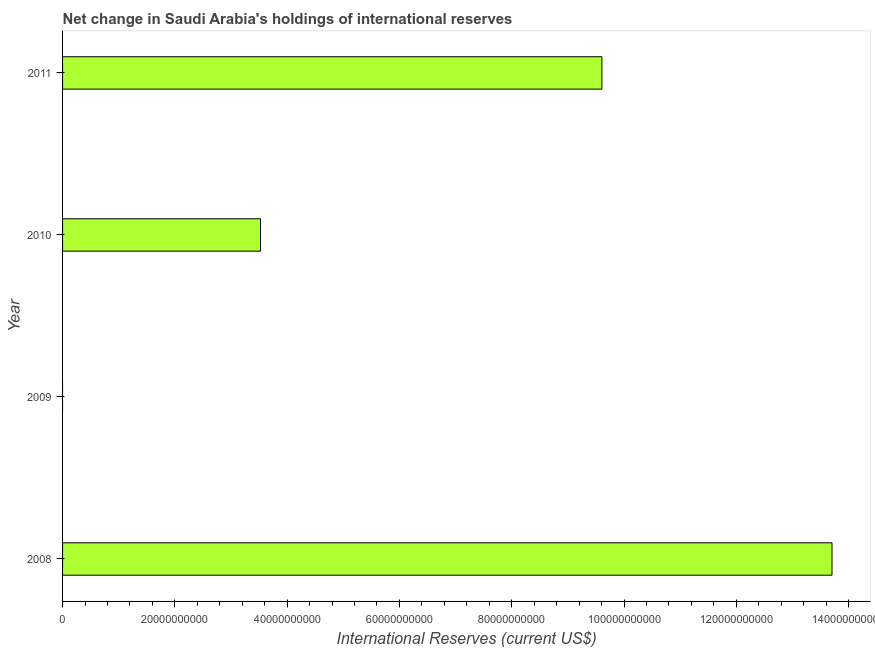Does the graph contain grids?
Your answer should be very brief. No. What is the title of the graph?
Provide a short and direct response. Net change in Saudi Arabia's holdings of international reserves. What is the label or title of the X-axis?
Make the answer very short. International Reserves (current US$). What is the reserves and related items in 2011?
Provide a short and direct response. 9.61e+1. Across all years, what is the maximum reserves and related items?
Offer a very short reply. 1.37e+11. What is the sum of the reserves and related items?
Ensure brevity in your answer.  2.68e+11. What is the difference between the reserves and related items in 2010 and 2011?
Offer a terse response. -6.08e+1. What is the average reserves and related items per year?
Make the answer very short. 6.71e+1. What is the median reserves and related items?
Provide a succinct answer. 6.57e+1. What is the ratio of the reserves and related items in 2008 to that in 2011?
Keep it short and to the point. 1.43. Is the reserves and related items in 2008 less than that in 2011?
Your response must be concise. No. What is the difference between the highest and the second highest reserves and related items?
Keep it short and to the point. 4.10e+1. Is the sum of the reserves and related items in 2008 and 2010 greater than the maximum reserves and related items across all years?
Give a very brief answer. Yes. What is the difference between the highest and the lowest reserves and related items?
Ensure brevity in your answer.  1.37e+11. In how many years, is the reserves and related items greater than the average reserves and related items taken over all years?
Keep it short and to the point. 2. How many bars are there?
Your answer should be very brief. 3. How many years are there in the graph?
Your answer should be compact. 4. What is the difference between two consecutive major ticks on the X-axis?
Make the answer very short. 2.00e+1. What is the International Reserves (current US$) in 2008?
Your response must be concise. 1.37e+11. What is the International Reserves (current US$) of 2009?
Your answer should be very brief. 0. What is the International Reserves (current US$) of 2010?
Your answer should be compact. 3.53e+1. What is the International Reserves (current US$) in 2011?
Keep it short and to the point. 9.61e+1. What is the difference between the International Reserves (current US$) in 2008 and 2010?
Give a very brief answer. 1.02e+11. What is the difference between the International Reserves (current US$) in 2008 and 2011?
Your answer should be compact. 4.10e+1. What is the difference between the International Reserves (current US$) in 2010 and 2011?
Ensure brevity in your answer.  -6.08e+1. What is the ratio of the International Reserves (current US$) in 2008 to that in 2010?
Your answer should be compact. 3.89. What is the ratio of the International Reserves (current US$) in 2008 to that in 2011?
Ensure brevity in your answer.  1.43. What is the ratio of the International Reserves (current US$) in 2010 to that in 2011?
Your answer should be very brief. 0.37. 